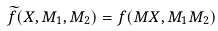Convert formula to latex. <formula><loc_0><loc_0><loc_500><loc_500>\widetilde { f } ( X , M _ { 1 } , M _ { 2 } ) = f ( M X , M _ { 1 } M _ { 2 } )</formula> 